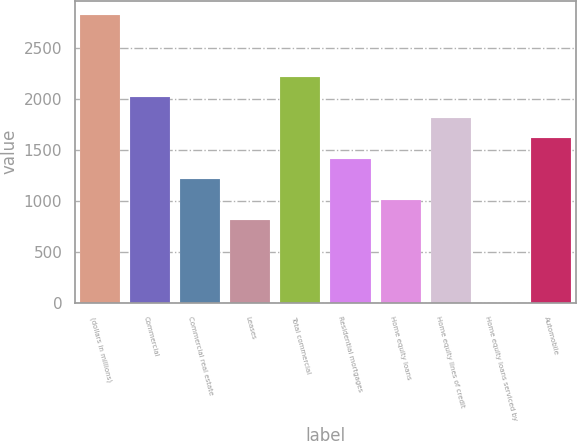Convert chart. <chart><loc_0><loc_0><loc_500><loc_500><bar_chart><fcel>(dollars in millions)<fcel>Commercial<fcel>Commercial real estate<fcel>Leases<fcel>Total commercial<fcel>Residential mortgages<fcel>Home equity loans<fcel>Home equity lines of credit<fcel>Home equity loans serviced by<fcel>Automobile<nl><fcel>2819.2<fcel>2014<fcel>1208.8<fcel>806.2<fcel>2215.3<fcel>1410.1<fcel>1007.5<fcel>1812.7<fcel>1<fcel>1611.4<nl></chart> 